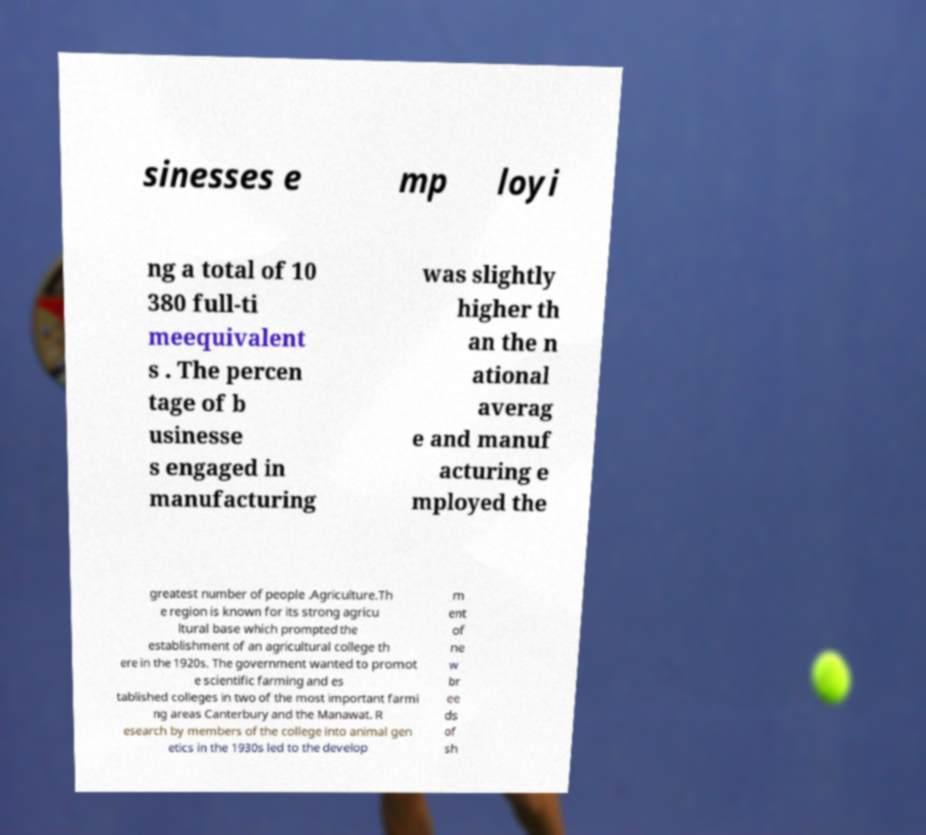Could you assist in decoding the text presented in this image and type it out clearly? sinesses e mp loyi ng a total of 10 380 full-ti meequivalent s . The percen tage of b usinesse s engaged in manufacturing was slightly higher th an the n ational averag e and manuf acturing e mployed the greatest number of people .Agriculture.Th e region is known for its strong agricu ltural base which prompted the establishment of an agricultural college th ere in the 1920s. The government wanted to promot e scientific farming and es tablished colleges in two of the most important farmi ng areas Canterbury and the Manawat. R esearch by members of the college into animal gen etics in the 1930s led to the develop m ent of ne w br ee ds of sh 